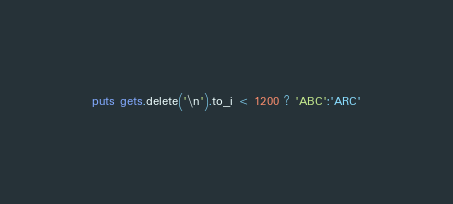Convert code to text. <code><loc_0><loc_0><loc_500><loc_500><_Ruby_>puts gets.delete('\n').to_i < 1200 ? 'ABC':'ARC'</code> 